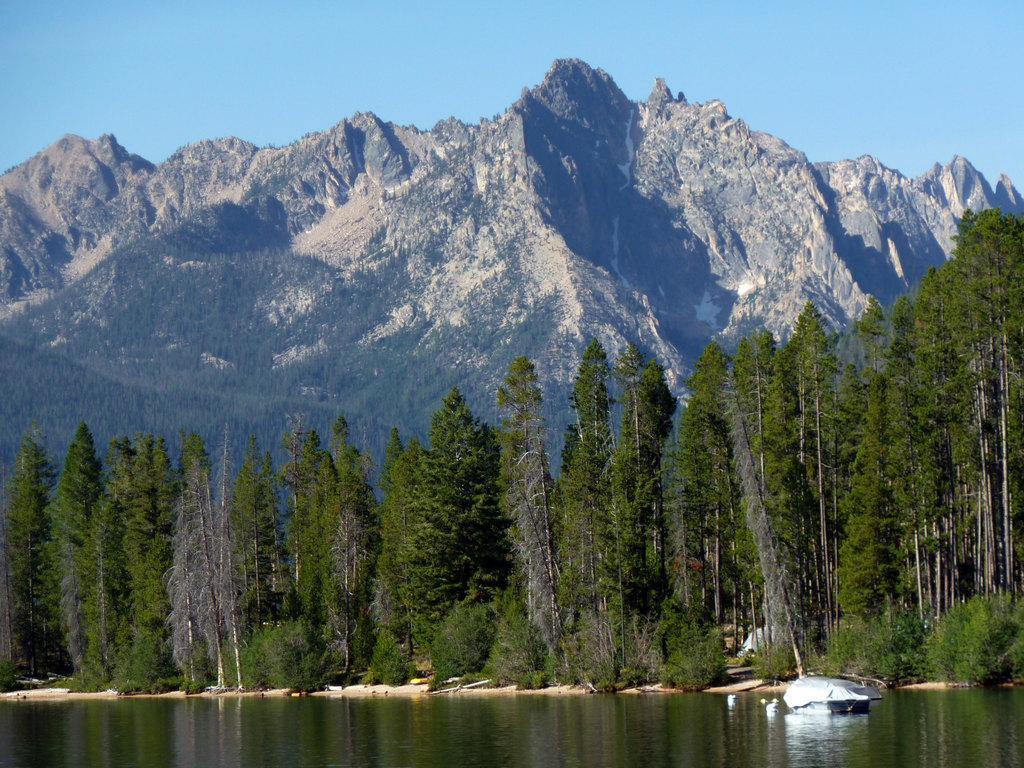How would you summarize this image in a sentence or two? In this image there is an object in the water. There are few trees on the land. Behind there is hill. Top of image there is sky. 